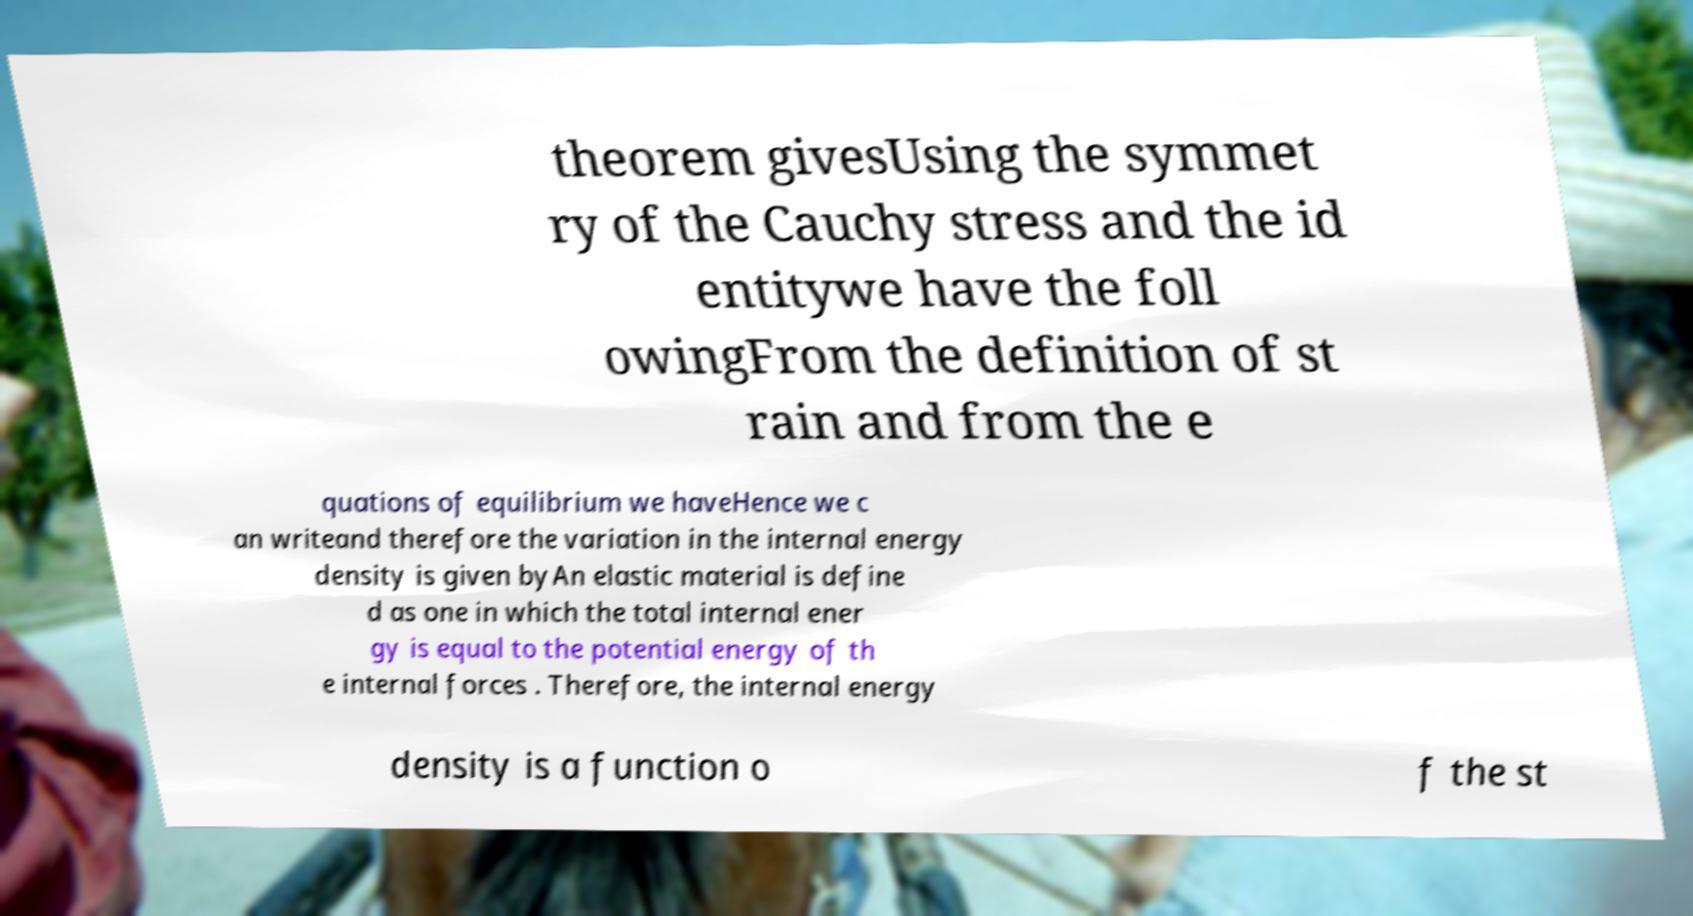Could you extract and type out the text from this image? theorem givesUsing the symmet ry of the Cauchy stress and the id entitywe have the foll owingFrom the definition of st rain and from the e quations of equilibrium we haveHence we c an writeand therefore the variation in the internal energy density is given byAn elastic material is define d as one in which the total internal ener gy is equal to the potential energy of th e internal forces . Therefore, the internal energy density is a function o f the st 